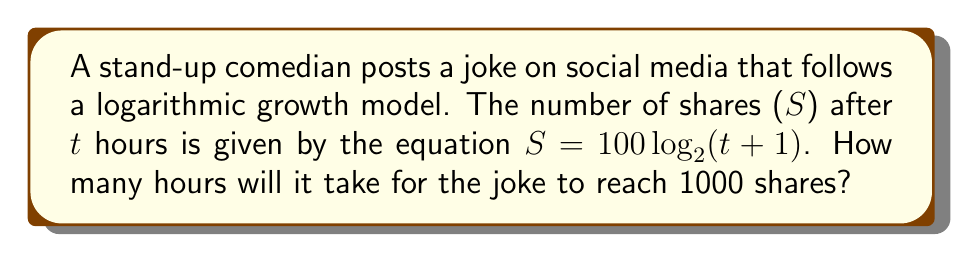Teach me how to tackle this problem. Let's approach this step-by-step:

1) We're given the equation $S = 100 \log_2(t+1)$, where S is the number of shares and t is the time in hours.

2) We want to find t when S = 1000. So, let's substitute this:

   $1000 = 100 \log_2(t+1)$

3) Divide both sides by 100:

   $10 = \log_2(t+1)$

4) Now, we need to solve for t. We can do this by applying $2^x$ to both sides:

   $2^{10} = 2^{\log_2(t+1)}$

5) The right side simplifies to just (t+1) because $2^{\log_2(x)} = x$:

   $2^{10} = t+1$

6) Calculate $2^{10}$:

   $1024 = t+1$

7) Subtract 1 from both sides:

   $1023 = t$

Therefore, it will take 1023 hours for the joke to reach 1000 shares.
Answer: 1023 hours 